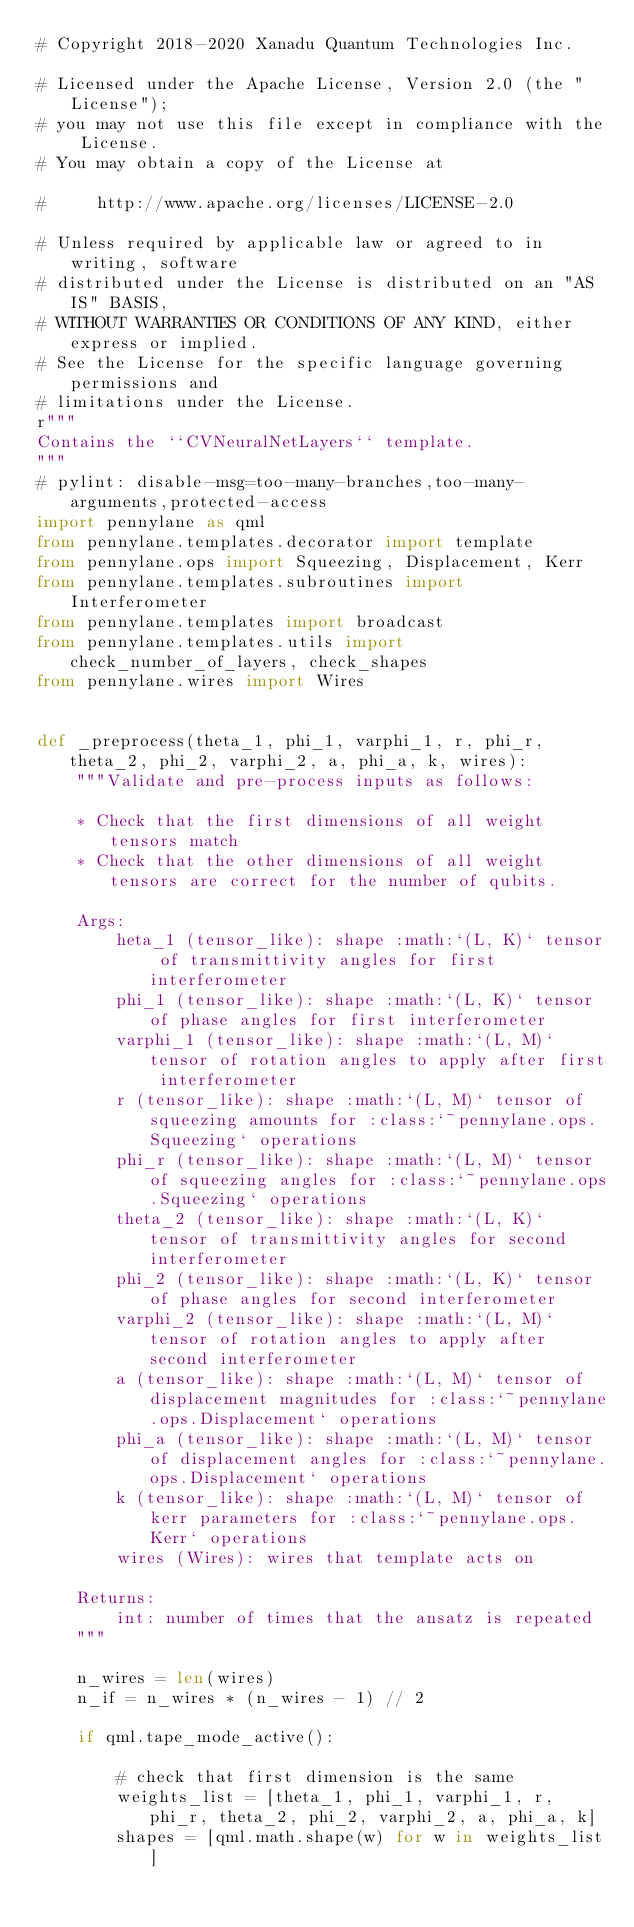<code> <loc_0><loc_0><loc_500><loc_500><_Python_># Copyright 2018-2020 Xanadu Quantum Technologies Inc.

# Licensed under the Apache License, Version 2.0 (the "License");
# you may not use this file except in compliance with the License.
# You may obtain a copy of the License at

#     http://www.apache.org/licenses/LICENSE-2.0

# Unless required by applicable law or agreed to in writing, software
# distributed under the License is distributed on an "AS IS" BASIS,
# WITHOUT WARRANTIES OR CONDITIONS OF ANY KIND, either express or implied.
# See the License for the specific language governing permissions and
# limitations under the License.
r"""
Contains the ``CVNeuralNetLayers`` template.
"""
# pylint: disable-msg=too-many-branches,too-many-arguments,protected-access
import pennylane as qml
from pennylane.templates.decorator import template
from pennylane.ops import Squeezing, Displacement, Kerr
from pennylane.templates.subroutines import Interferometer
from pennylane.templates import broadcast
from pennylane.templates.utils import check_number_of_layers, check_shapes
from pennylane.wires import Wires


def _preprocess(theta_1, phi_1, varphi_1, r, phi_r, theta_2, phi_2, varphi_2, a, phi_a, k, wires):
    """Validate and pre-process inputs as follows:

    * Check that the first dimensions of all weight tensors match
    * Check that the other dimensions of all weight tensors are correct for the number of qubits.

    Args:
        heta_1 (tensor_like): shape :math:`(L, K)` tensor of transmittivity angles for first interferometer
        phi_1 (tensor_like): shape :math:`(L, K)` tensor of phase angles for first interferometer
        varphi_1 (tensor_like): shape :math:`(L, M)` tensor of rotation angles to apply after first interferometer
        r (tensor_like): shape :math:`(L, M)` tensor of squeezing amounts for :class:`~pennylane.ops.Squeezing` operations
        phi_r (tensor_like): shape :math:`(L, M)` tensor of squeezing angles for :class:`~pennylane.ops.Squeezing` operations
        theta_2 (tensor_like): shape :math:`(L, K)` tensor of transmittivity angles for second interferometer
        phi_2 (tensor_like): shape :math:`(L, K)` tensor of phase angles for second interferometer
        varphi_2 (tensor_like): shape :math:`(L, M)` tensor of rotation angles to apply after second interferometer
        a (tensor_like): shape :math:`(L, M)` tensor of displacement magnitudes for :class:`~pennylane.ops.Displacement` operations
        phi_a (tensor_like): shape :math:`(L, M)` tensor of displacement angles for :class:`~pennylane.ops.Displacement` operations
        k (tensor_like): shape :math:`(L, M)` tensor of kerr parameters for :class:`~pennylane.ops.Kerr` operations
        wires (Wires): wires that template acts on

    Returns:
        int: number of times that the ansatz is repeated
    """

    n_wires = len(wires)
    n_if = n_wires * (n_wires - 1) // 2

    if qml.tape_mode_active():

        # check that first dimension is the same
        weights_list = [theta_1, phi_1, varphi_1, r, phi_r, theta_2, phi_2, varphi_2, a, phi_a, k]
        shapes = [qml.math.shape(w) for w in weights_list]
</code> 